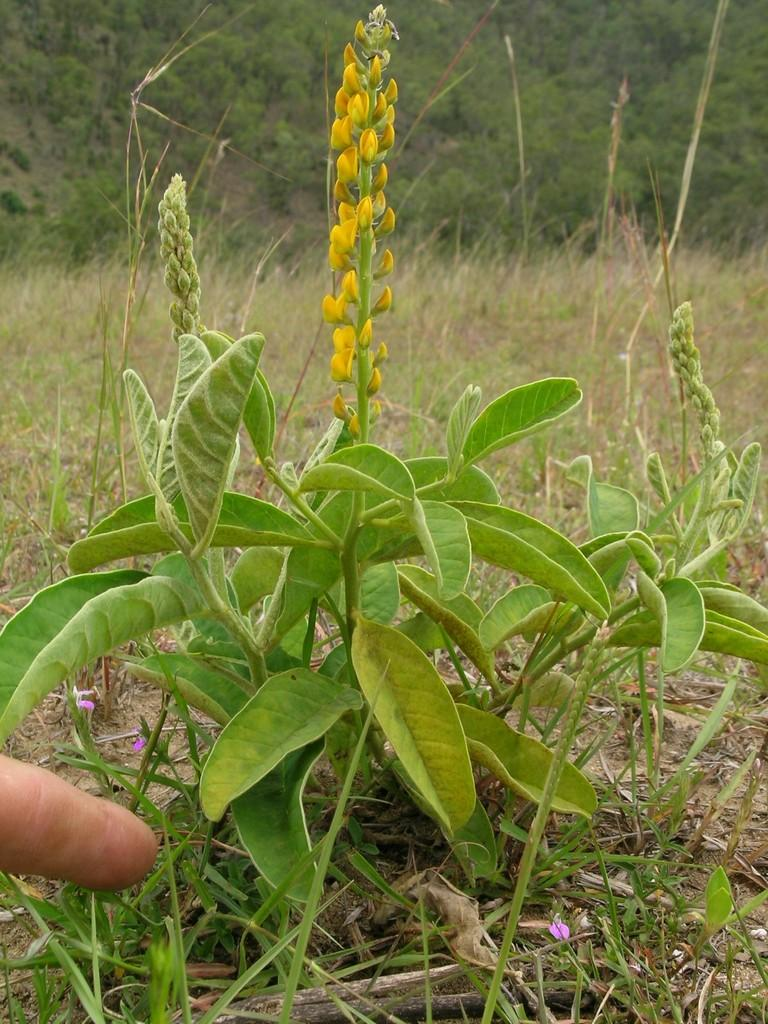What type of plant is in the image? There is a plant in the image, but the specific type cannot be determined from the provided facts. What can be seen in the background of the image? There are trees and grass in the background of the image. Can you describe any human presence in the image? A person's finger is visible in the image. What is the impulse of the plant in the image? There is no impulse associated with the plant in the image, as it is a static object. Can you describe the partner of the person whose finger is visible in the image? There is no information about a partner or any other person in the image. 